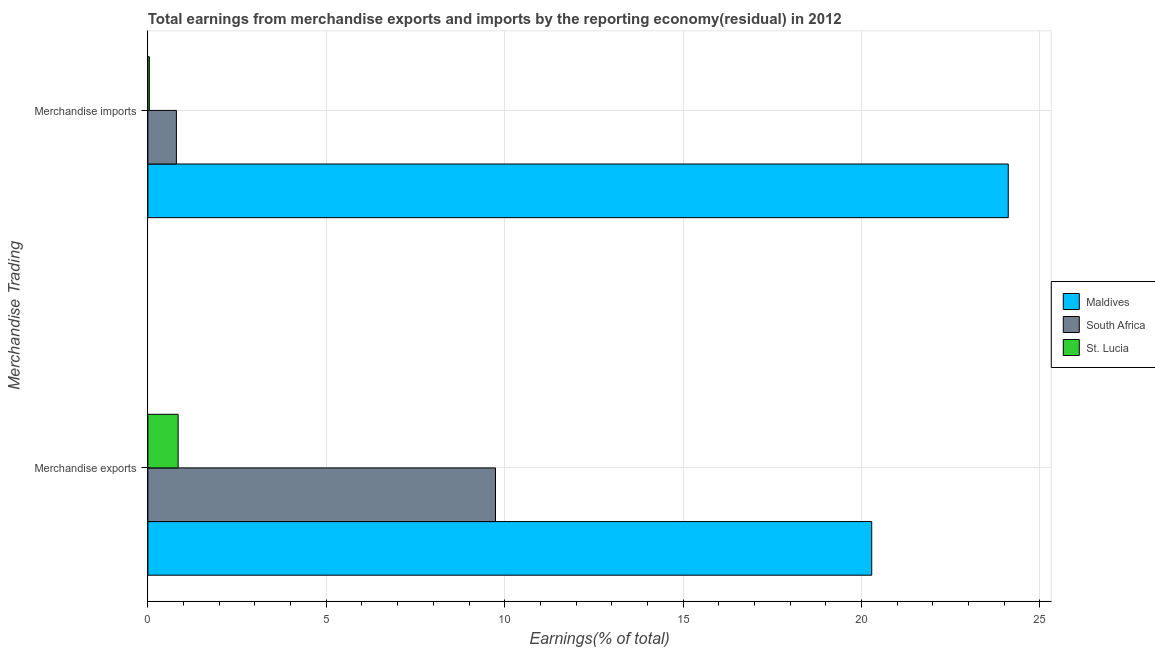How many different coloured bars are there?
Make the answer very short. 3. Are the number of bars on each tick of the Y-axis equal?
Ensure brevity in your answer.  Yes. What is the earnings from merchandise exports in St. Lucia?
Your response must be concise. 0.85. Across all countries, what is the maximum earnings from merchandise exports?
Give a very brief answer. 20.29. Across all countries, what is the minimum earnings from merchandise exports?
Offer a terse response. 0.85. In which country was the earnings from merchandise imports maximum?
Keep it short and to the point. Maldives. In which country was the earnings from merchandise exports minimum?
Keep it short and to the point. St. Lucia. What is the total earnings from merchandise imports in the graph?
Your answer should be very brief. 24.95. What is the difference between the earnings from merchandise exports in Maldives and that in South Africa?
Give a very brief answer. 10.54. What is the difference between the earnings from merchandise imports in South Africa and the earnings from merchandise exports in St. Lucia?
Provide a short and direct response. -0.05. What is the average earnings from merchandise exports per country?
Offer a very short reply. 10.29. What is the difference between the earnings from merchandise exports and earnings from merchandise imports in Maldives?
Your answer should be very brief. -3.83. In how many countries, is the earnings from merchandise exports greater than 5 %?
Your answer should be compact. 2. What is the ratio of the earnings from merchandise imports in St. Lucia to that in South Africa?
Give a very brief answer. 0.05. Is the earnings from merchandise exports in Maldives less than that in St. Lucia?
Keep it short and to the point. No. In how many countries, is the earnings from merchandise exports greater than the average earnings from merchandise exports taken over all countries?
Provide a short and direct response. 1. What does the 2nd bar from the top in Merchandise exports represents?
Make the answer very short. South Africa. What does the 3rd bar from the bottom in Merchandise exports represents?
Your answer should be compact. St. Lucia. How many bars are there?
Give a very brief answer. 6. Are all the bars in the graph horizontal?
Provide a short and direct response. Yes. How many countries are there in the graph?
Your answer should be very brief. 3. Are the values on the major ticks of X-axis written in scientific E-notation?
Give a very brief answer. No. Does the graph contain any zero values?
Keep it short and to the point. No. Does the graph contain grids?
Provide a short and direct response. Yes. How many legend labels are there?
Ensure brevity in your answer.  3. What is the title of the graph?
Keep it short and to the point. Total earnings from merchandise exports and imports by the reporting economy(residual) in 2012. What is the label or title of the X-axis?
Give a very brief answer. Earnings(% of total). What is the label or title of the Y-axis?
Offer a terse response. Merchandise Trading. What is the Earnings(% of total) of Maldives in Merchandise exports?
Offer a very short reply. 20.29. What is the Earnings(% of total) of South Africa in Merchandise exports?
Offer a terse response. 9.74. What is the Earnings(% of total) in St. Lucia in Merchandise exports?
Offer a terse response. 0.85. What is the Earnings(% of total) in Maldives in Merchandise imports?
Your answer should be compact. 24.11. What is the Earnings(% of total) in South Africa in Merchandise imports?
Offer a very short reply. 0.8. What is the Earnings(% of total) in St. Lucia in Merchandise imports?
Give a very brief answer. 0.04. Across all Merchandise Trading, what is the maximum Earnings(% of total) of Maldives?
Offer a very short reply. 24.11. Across all Merchandise Trading, what is the maximum Earnings(% of total) in South Africa?
Give a very brief answer. 9.74. Across all Merchandise Trading, what is the maximum Earnings(% of total) of St. Lucia?
Your answer should be very brief. 0.85. Across all Merchandise Trading, what is the minimum Earnings(% of total) in Maldives?
Make the answer very short. 20.29. Across all Merchandise Trading, what is the minimum Earnings(% of total) in South Africa?
Your answer should be compact. 0.8. Across all Merchandise Trading, what is the minimum Earnings(% of total) of St. Lucia?
Keep it short and to the point. 0.04. What is the total Earnings(% of total) of Maldives in the graph?
Make the answer very short. 44.4. What is the total Earnings(% of total) of South Africa in the graph?
Offer a very short reply. 10.54. What is the total Earnings(% of total) of St. Lucia in the graph?
Offer a very short reply. 0.89. What is the difference between the Earnings(% of total) of Maldives in Merchandise exports and that in Merchandise imports?
Your answer should be compact. -3.83. What is the difference between the Earnings(% of total) of South Africa in Merchandise exports and that in Merchandise imports?
Your response must be concise. 8.94. What is the difference between the Earnings(% of total) of St. Lucia in Merchandise exports and that in Merchandise imports?
Provide a short and direct response. 0.81. What is the difference between the Earnings(% of total) in Maldives in Merchandise exports and the Earnings(% of total) in South Africa in Merchandise imports?
Offer a very short reply. 19.49. What is the difference between the Earnings(% of total) of Maldives in Merchandise exports and the Earnings(% of total) of St. Lucia in Merchandise imports?
Ensure brevity in your answer.  20.25. What is the difference between the Earnings(% of total) of South Africa in Merchandise exports and the Earnings(% of total) of St. Lucia in Merchandise imports?
Ensure brevity in your answer.  9.7. What is the average Earnings(% of total) of Maldives per Merchandise Trading?
Ensure brevity in your answer.  22.2. What is the average Earnings(% of total) of South Africa per Merchandise Trading?
Give a very brief answer. 5.27. What is the average Earnings(% of total) of St. Lucia per Merchandise Trading?
Give a very brief answer. 0.44. What is the difference between the Earnings(% of total) in Maldives and Earnings(% of total) in South Africa in Merchandise exports?
Give a very brief answer. 10.54. What is the difference between the Earnings(% of total) in Maldives and Earnings(% of total) in St. Lucia in Merchandise exports?
Offer a terse response. 19.44. What is the difference between the Earnings(% of total) in South Africa and Earnings(% of total) in St. Lucia in Merchandise exports?
Keep it short and to the point. 8.89. What is the difference between the Earnings(% of total) in Maldives and Earnings(% of total) in South Africa in Merchandise imports?
Make the answer very short. 23.31. What is the difference between the Earnings(% of total) of Maldives and Earnings(% of total) of St. Lucia in Merchandise imports?
Offer a very short reply. 24.07. What is the difference between the Earnings(% of total) of South Africa and Earnings(% of total) of St. Lucia in Merchandise imports?
Give a very brief answer. 0.76. What is the ratio of the Earnings(% of total) in Maldives in Merchandise exports to that in Merchandise imports?
Keep it short and to the point. 0.84. What is the ratio of the Earnings(% of total) of South Africa in Merchandise exports to that in Merchandise imports?
Your answer should be very brief. 12.18. What is the ratio of the Earnings(% of total) in St. Lucia in Merchandise exports to that in Merchandise imports?
Make the answer very short. 20.81. What is the difference between the highest and the second highest Earnings(% of total) of Maldives?
Offer a very short reply. 3.83. What is the difference between the highest and the second highest Earnings(% of total) in South Africa?
Your response must be concise. 8.94. What is the difference between the highest and the second highest Earnings(% of total) of St. Lucia?
Your response must be concise. 0.81. What is the difference between the highest and the lowest Earnings(% of total) in Maldives?
Offer a terse response. 3.83. What is the difference between the highest and the lowest Earnings(% of total) of South Africa?
Your answer should be very brief. 8.94. What is the difference between the highest and the lowest Earnings(% of total) of St. Lucia?
Keep it short and to the point. 0.81. 